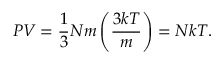<formula> <loc_0><loc_0><loc_500><loc_500>P V = { \frac { 1 } { 3 } } N m \left ( { \frac { 3 k T } { m } } \right ) = N k T .</formula> 